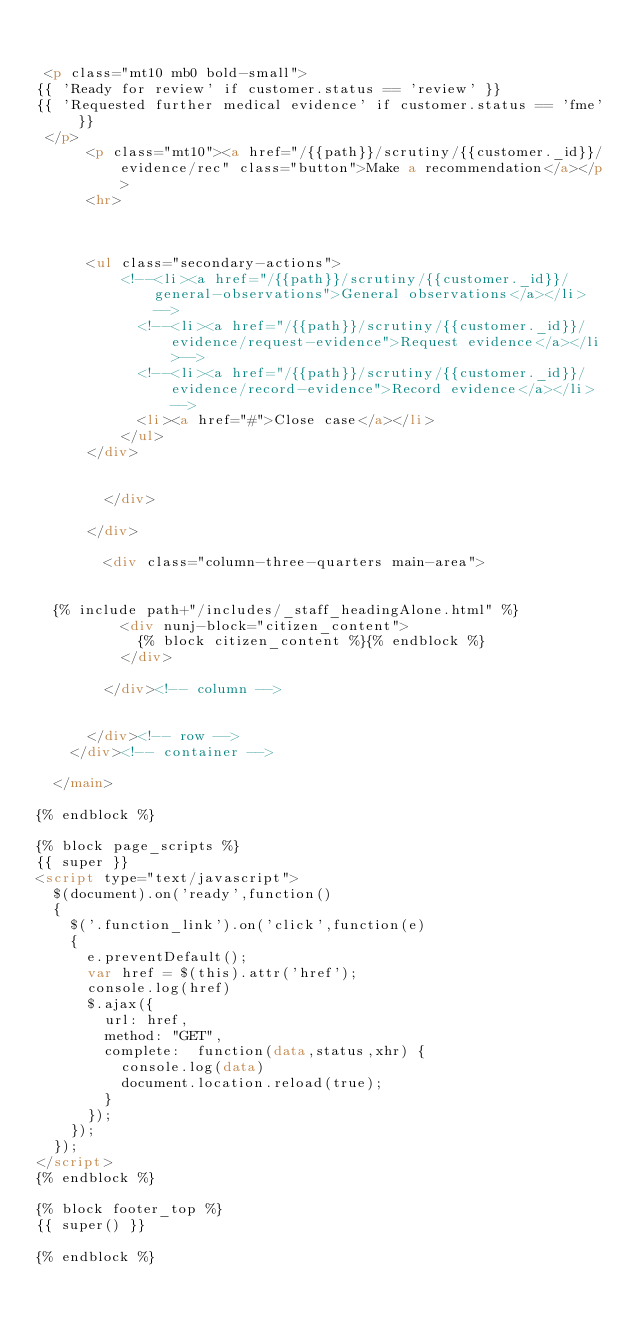<code> <loc_0><loc_0><loc_500><loc_500><_HTML_>      	 
		 
 <p class="mt10 mb0 bold-small">
{{ 'Ready for review' if customer.status == 'review' }}
{{ 'Requested further medical evidence' if customer.status == 'fme' }}
 </p>
		  <p class="mt10"><a href="/{{path}}/scrutiny/{{customer._id}}/evidence/rec" class="button">Make a recommendation</a></p>
		  <hr>
		  
		  
		  
		  <ul class="secondary-actions">
          <!--<li><a href="/{{path}}/scrutiny/{{customer._id}}/general-observations">General observations</a></li>-->
		  		  <!--<li><a href="/{{path}}/scrutiny/{{customer._id}}/evidence/request-evidence">Request evidence</a></li>-->
			      <!--<li><a href="/{{path}}/scrutiny/{{customer._id}}/evidence/record-evidence">Record evidence</a></li> -->
			      <li><a href="#">Close case</a></li>
		      </ul>
		  </div>
      	
      	
      	</div>
      
      </div>
      
        <div class="column-three-quarters main-area">
        

  {% include path+"/includes/_staff_headingAlone.html" %}
          <div nunj-block="citizen_content">
            {% block citizen_content %}{% endblock %}
          </div>

        </div><!-- column -->
        
        
      </div><!-- row -->
    </div><!-- container -->

  </main>

{% endblock %}

{% block page_scripts %}
{{ super }}
<script type="text/javascript">
  $(document).on('ready',function()
  {
    $('.function_link').on('click',function(e)
    {
      e.preventDefault();
      var href = $(this).attr('href');
      console.log(href)
      $.ajax({
        url: href,
        method: "GET",
        complete:  function(data,status,xhr) {
          console.log(data)
          document.location.reload(true);
        }
      });
    });
  });
</script>
{% endblock %}

{% block footer_top %}
{{ super() }}

{% endblock %}
</code> 